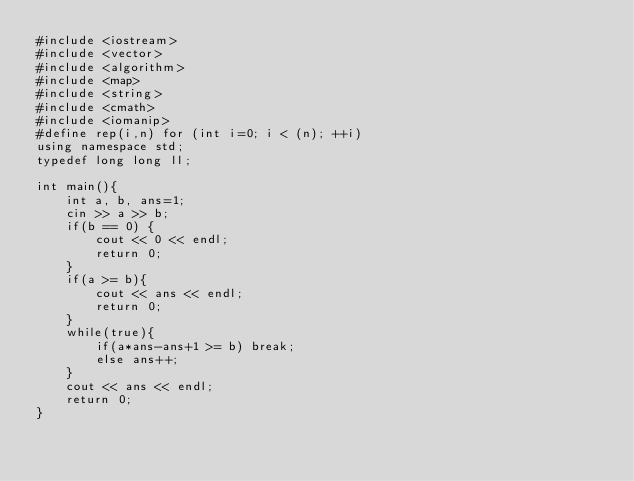<code> <loc_0><loc_0><loc_500><loc_500><_C++_>#include <iostream>
#include <vector>
#include <algorithm>
#include <map>
#include <string>
#include <cmath>
#include <iomanip>
#define rep(i,n) for (int i=0; i < (n); ++i)
using namespace std;
typedef long long ll;

int main(){
    int a, b, ans=1;
    cin >> a >> b;
    if(b == 0) {
        cout << 0 << endl;
        return 0;
    }
    if(a >= b){
        cout << ans << endl;
        return 0;
    }
    while(true){
        if(a*ans-ans+1 >= b) break;
        else ans++;
    }
    cout << ans << endl;
    return 0;
}</code> 